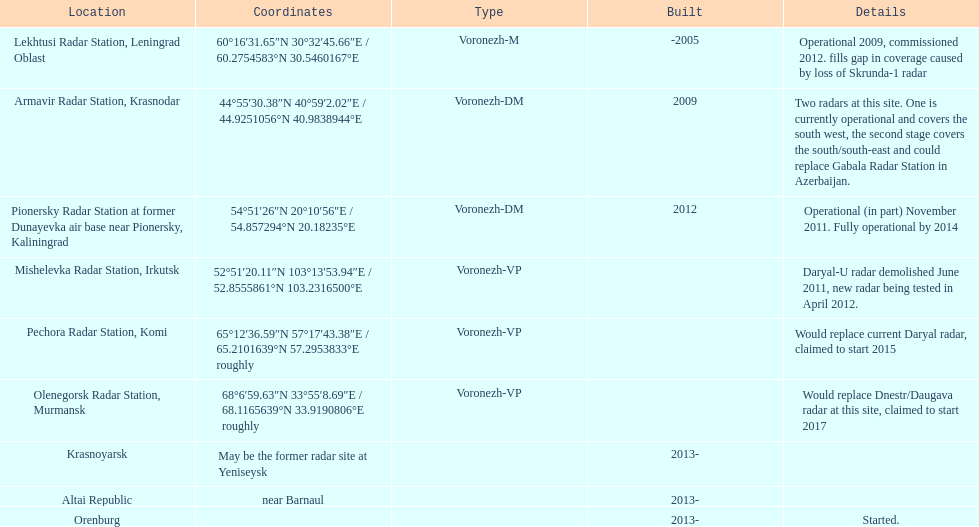How long did it take the pionersky radar station to go from partially operational to fully operational? 3 years. 